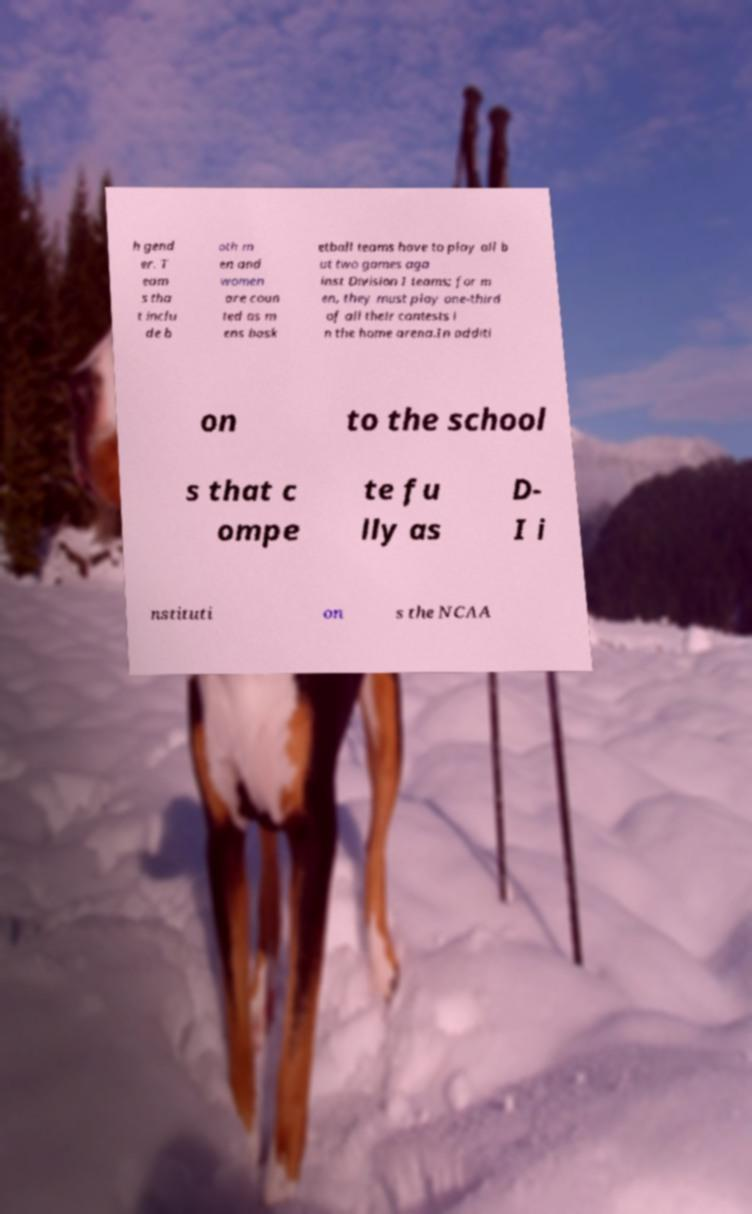Could you extract and type out the text from this image? h gend er. T eam s tha t inclu de b oth m en and women are coun ted as m ens bask etball teams have to play all b ut two games aga inst Division I teams; for m en, they must play one-third of all their contests i n the home arena.In additi on to the school s that c ompe te fu lly as D- I i nstituti on s the NCAA 